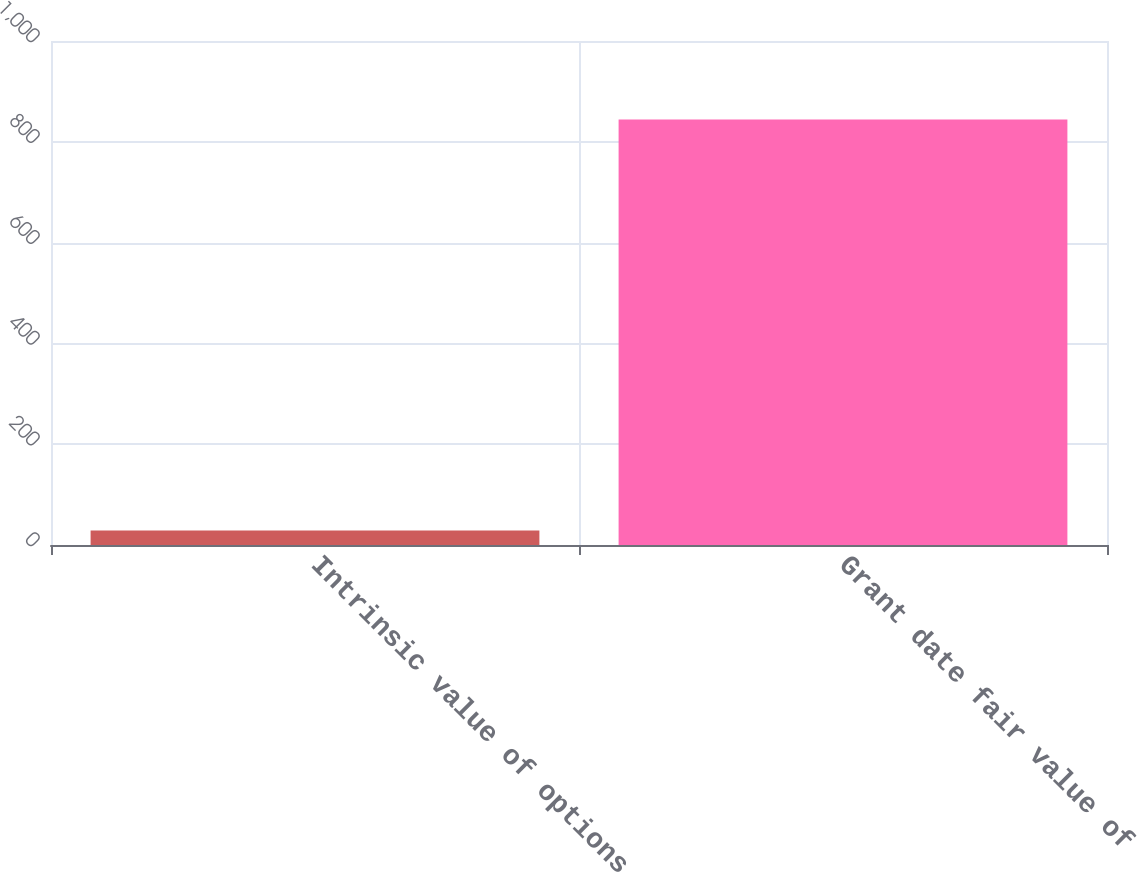<chart> <loc_0><loc_0><loc_500><loc_500><bar_chart><fcel>Intrinsic value of options<fcel>Grant date fair value of<nl><fcel>29<fcel>844<nl></chart> 